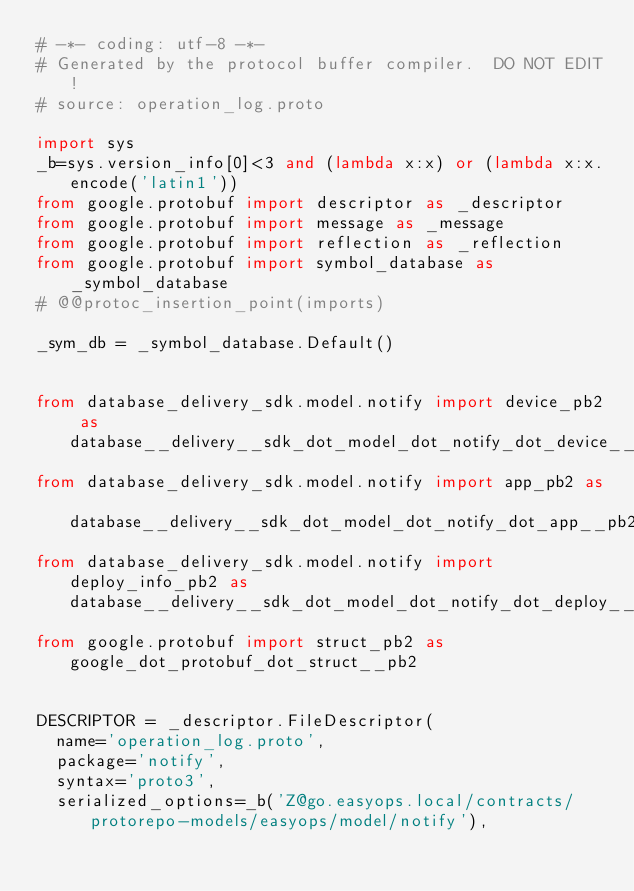<code> <loc_0><loc_0><loc_500><loc_500><_Python_># -*- coding: utf-8 -*-
# Generated by the protocol buffer compiler.  DO NOT EDIT!
# source: operation_log.proto

import sys
_b=sys.version_info[0]<3 and (lambda x:x) or (lambda x:x.encode('latin1'))
from google.protobuf import descriptor as _descriptor
from google.protobuf import message as _message
from google.protobuf import reflection as _reflection
from google.protobuf import symbol_database as _symbol_database
# @@protoc_insertion_point(imports)

_sym_db = _symbol_database.Default()


from database_delivery_sdk.model.notify import device_pb2 as database__delivery__sdk_dot_model_dot_notify_dot_device__pb2
from database_delivery_sdk.model.notify import app_pb2 as database__delivery__sdk_dot_model_dot_notify_dot_app__pb2
from database_delivery_sdk.model.notify import deploy_info_pb2 as database__delivery__sdk_dot_model_dot_notify_dot_deploy__info__pb2
from google.protobuf import struct_pb2 as google_dot_protobuf_dot_struct__pb2


DESCRIPTOR = _descriptor.FileDescriptor(
  name='operation_log.proto',
  package='notify',
  syntax='proto3',
  serialized_options=_b('Z@go.easyops.local/contracts/protorepo-models/easyops/model/notify'),</code> 